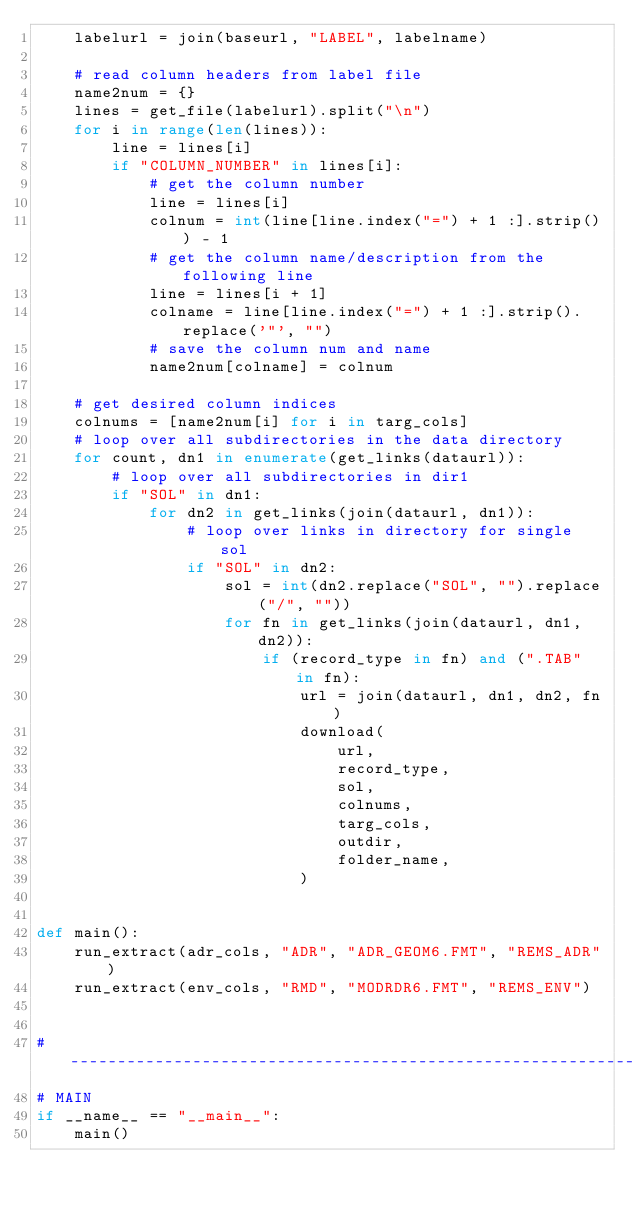<code> <loc_0><loc_0><loc_500><loc_500><_Python_>    labelurl = join(baseurl, "LABEL", labelname)

    # read column headers from label file
    name2num = {}
    lines = get_file(labelurl).split("\n")
    for i in range(len(lines)):
        line = lines[i]
        if "COLUMN_NUMBER" in lines[i]:
            # get the column number
            line = lines[i]
            colnum = int(line[line.index("=") + 1 :].strip()) - 1
            # get the column name/description from the following line
            line = lines[i + 1]
            colname = line[line.index("=") + 1 :].strip().replace('"', "")
            # save the column num and name
            name2num[colname] = colnum

    # get desired column indices
    colnums = [name2num[i] for i in targ_cols]
    # loop over all subdirectories in the data directory
    for count, dn1 in enumerate(get_links(dataurl)):
        # loop over all subdirectories in dir1
        if "SOL" in dn1:
            for dn2 in get_links(join(dataurl, dn1)):
                # loop over links in directory for single sol
                if "SOL" in dn2:
                    sol = int(dn2.replace("SOL", "").replace("/", ""))
                    for fn in get_links(join(dataurl, dn1, dn2)):
                        if (record_type in fn) and (".TAB" in fn):
                            url = join(dataurl, dn1, dn2, fn)
                            download(
                                url,
                                record_type,
                                sol,
                                colnums,
                                targ_cols,
                                outdir,
                                folder_name,
                            )


def main():
    run_extract(adr_cols, "ADR", "ADR_GEOM6.FMT", "REMS_ADR")
    run_extract(env_cols, "RMD", "MODRDR6.FMT", "REMS_ENV")


# -------------------------------------------------------------------------------
# MAIN
if __name__ == "__main__":
    main()
</code> 